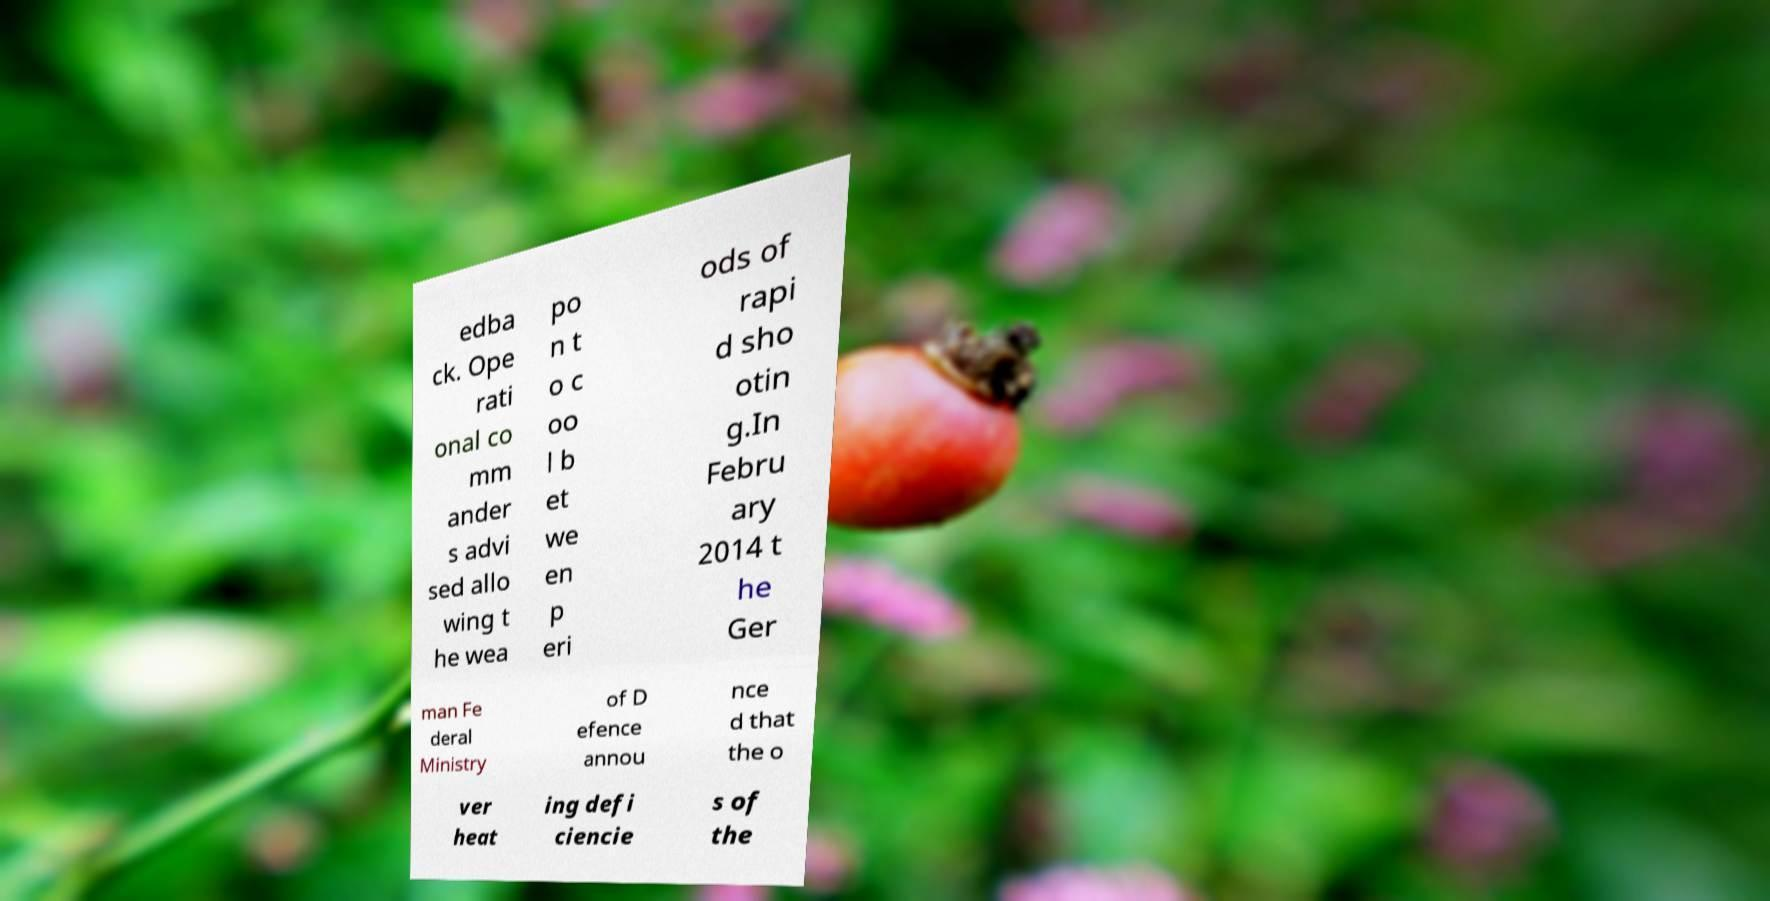Please identify and transcribe the text found in this image. edba ck. Ope rati onal co mm ander s advi sed allo wing t he wea po n t o c oo l b et we en p eri ods of rapi d sho otin g.In Febru ary 2014 t he Ger man Fe deral Ministry of D efence annou nce d that the o ver heat ing defi ciencie s of the 